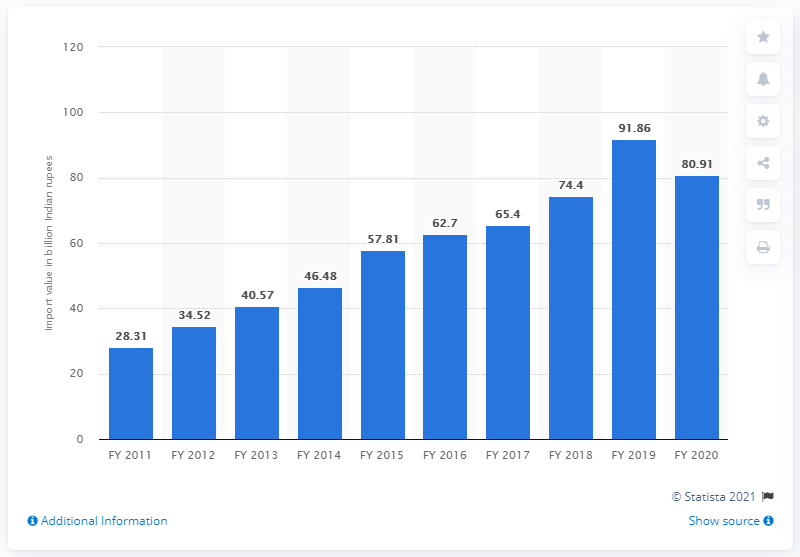Draw attention to some important aspects in this diagram. The import value of pulp and waste paper in India during the fiscal year 2019 was 91.86. In fiscal year 2020, the value of pulp and waste paper imported into India was 80.91. 